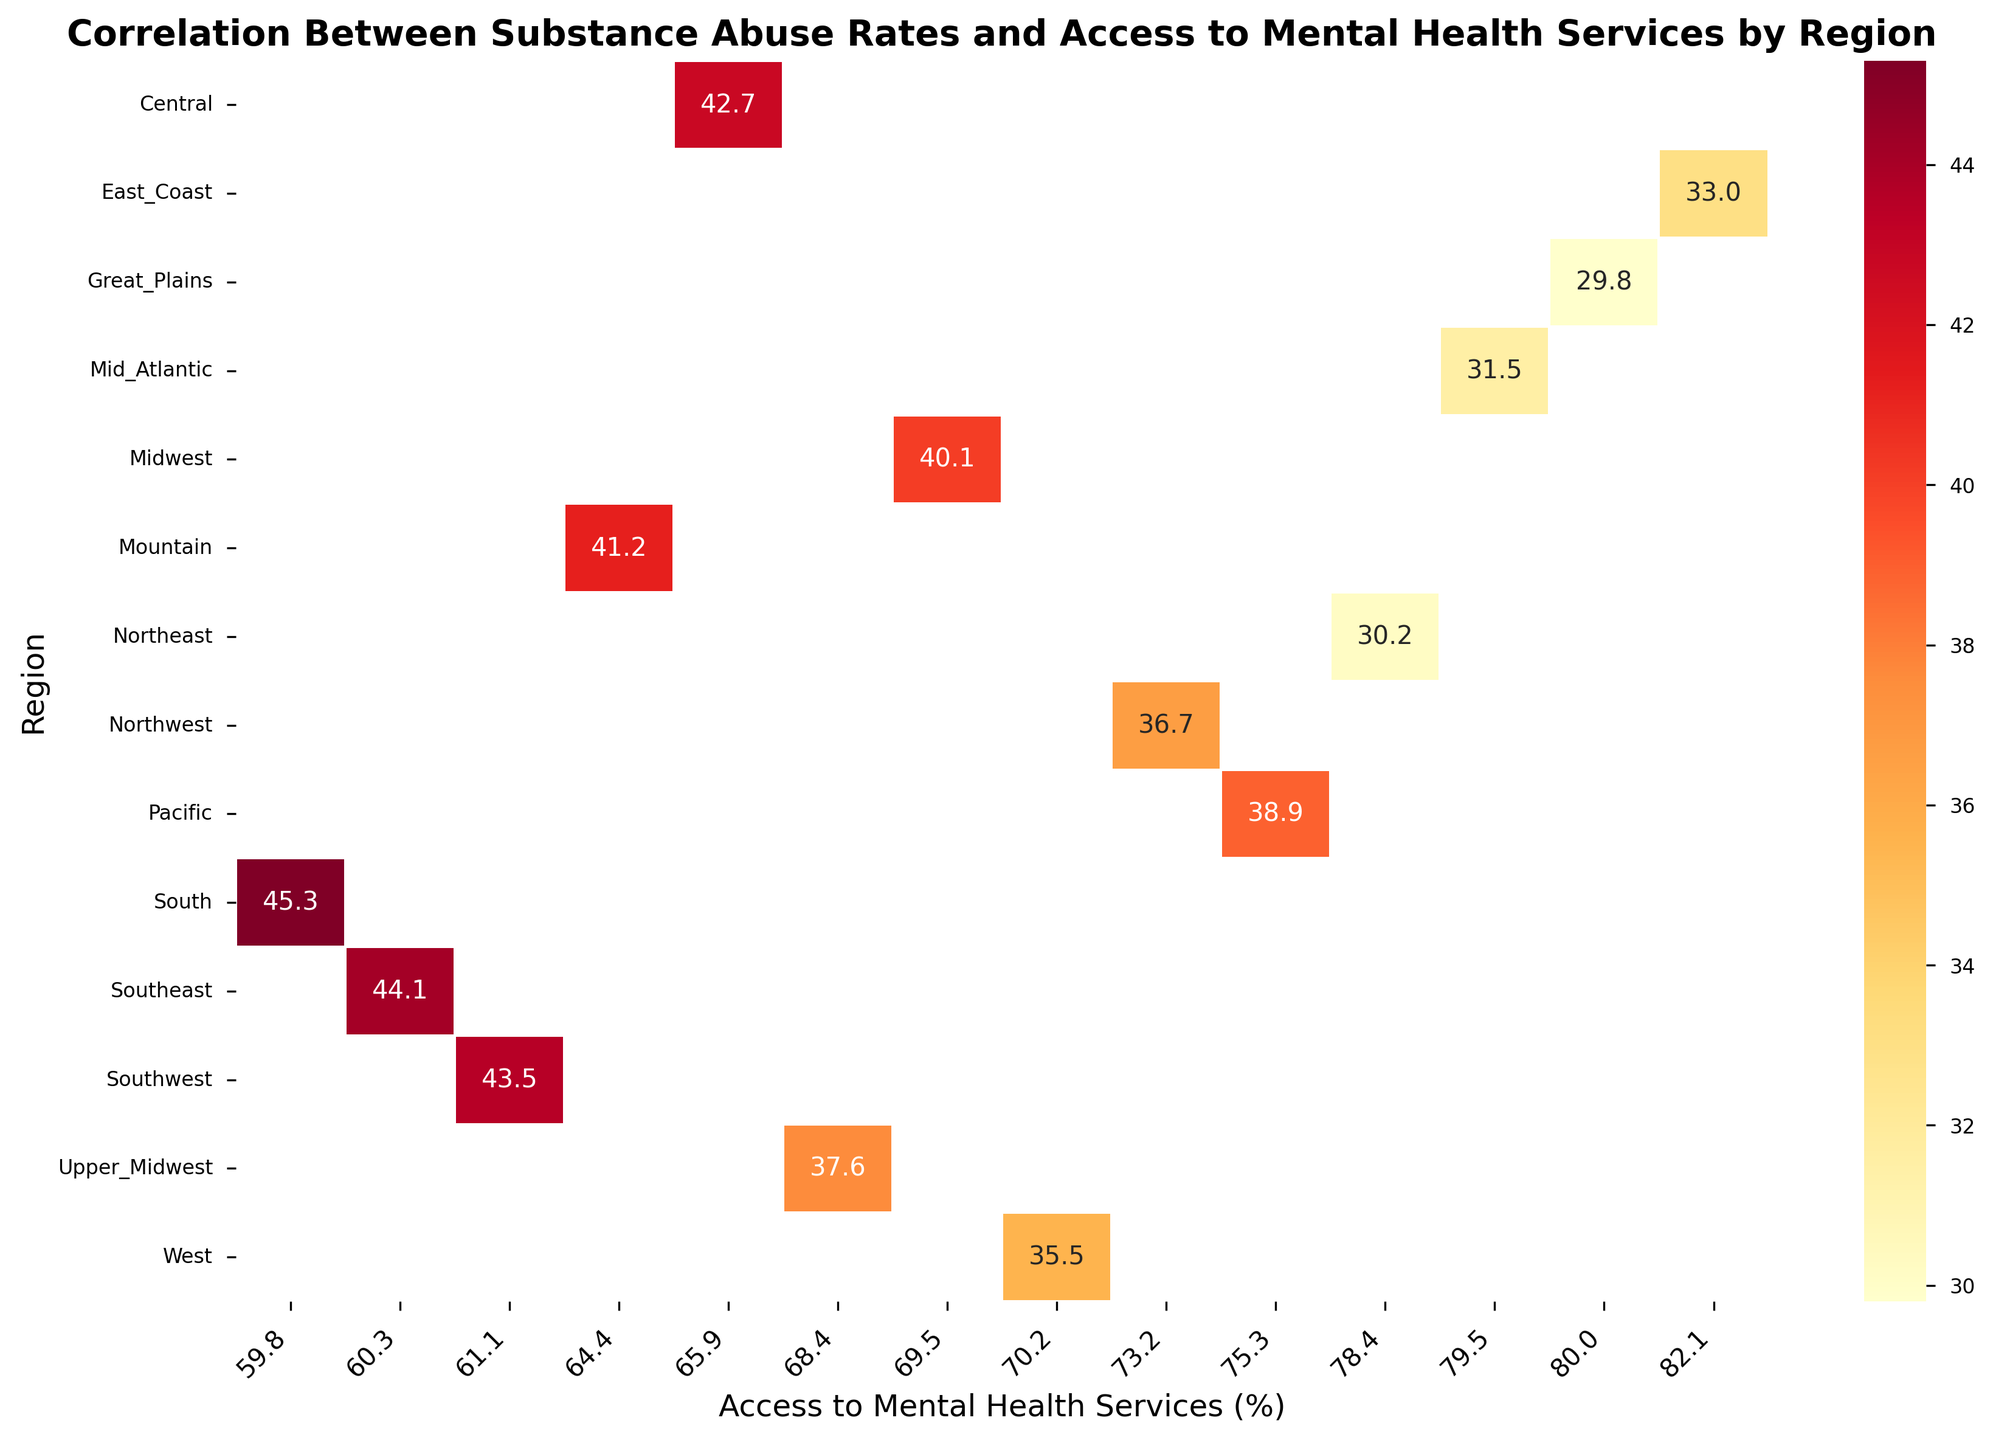Which region has the highest substance abuse rate? By looking at the figure, find the darkest red cell that corresponds to the highest substance abuse rate, and see which region it belongs to.
Answer: South Which region has the lowest access to mental health services? Identify the cell with the lowest value for access to mental health services by looking for the lowest percentage on the x-axis. Then, find the region associated with this value.
Answer: South How does the substance abuse rate in the Pacific region compare to the West region? Identify both the Pacific and West regions on the y-axis, then compare their corresponding substance abuse rates on the x-axis by looking at the color intensity of the cells in those regions.
Answer: Pacific has a higher substance abuse rate than West Which region has both high substance abuse rates and low access to mental health services? Look for regions with high substance abuse rate values and low percentages of access to mental health services. Check the color intensities where darker reds indicate high abuse rates, and lower x-axis values indicate less access.
Answer: South What is the difference in substance abuse rates between the Southwest and Great Plains regions? Find the substance abuse rates for both the Southwest and Great Plains regions from the figure. Then, subtract the value for Great Plains from the Southwest.
Answer: 43.5 - 29.8 = 13.7 What relationship can you observe between substance abuse rates and access to mental health services? Observe the general trend indicated by the color intensity on the heatmap. Compare the gradient of colors from low access (left) to high access (right) to see if there's a noticeable pattern.
Answer: Higher substance abuse rates tend to correspond with lower access to mental health services Which region has nearly identical access to mental health services as the Northeast? Locate the substance abuse data point for the Northeast on the x-axis, then look for nearby regions with similar x-axis values for access to mental health services.
Answer: Great Plains By how much does the substance abuse rate in the Southeast region exceed that of the Mid-Atlantic? Locate the substance abuse rates for both the Southeast and Mid-Atlantic regions on the figure. Then, subtract the value for Mid-Atlantic from the Southeast.
Answer: 44.1 - 31.5 = 12.6 What is the average substance abuse rate across all regions shown in the figure? Find the substance abuse rates for all regions, sum them up and then divide by the number of regions to get the average.
Answer: (30.2 + 40.1 + 45.3 + 35.5 + 33.0 + 42.7 + 38.9 + 41.2 + 29.8 + 43.5 + 36.7 + 44.1 + 31.5 + 37.6) / 14 ≈ 37.6 